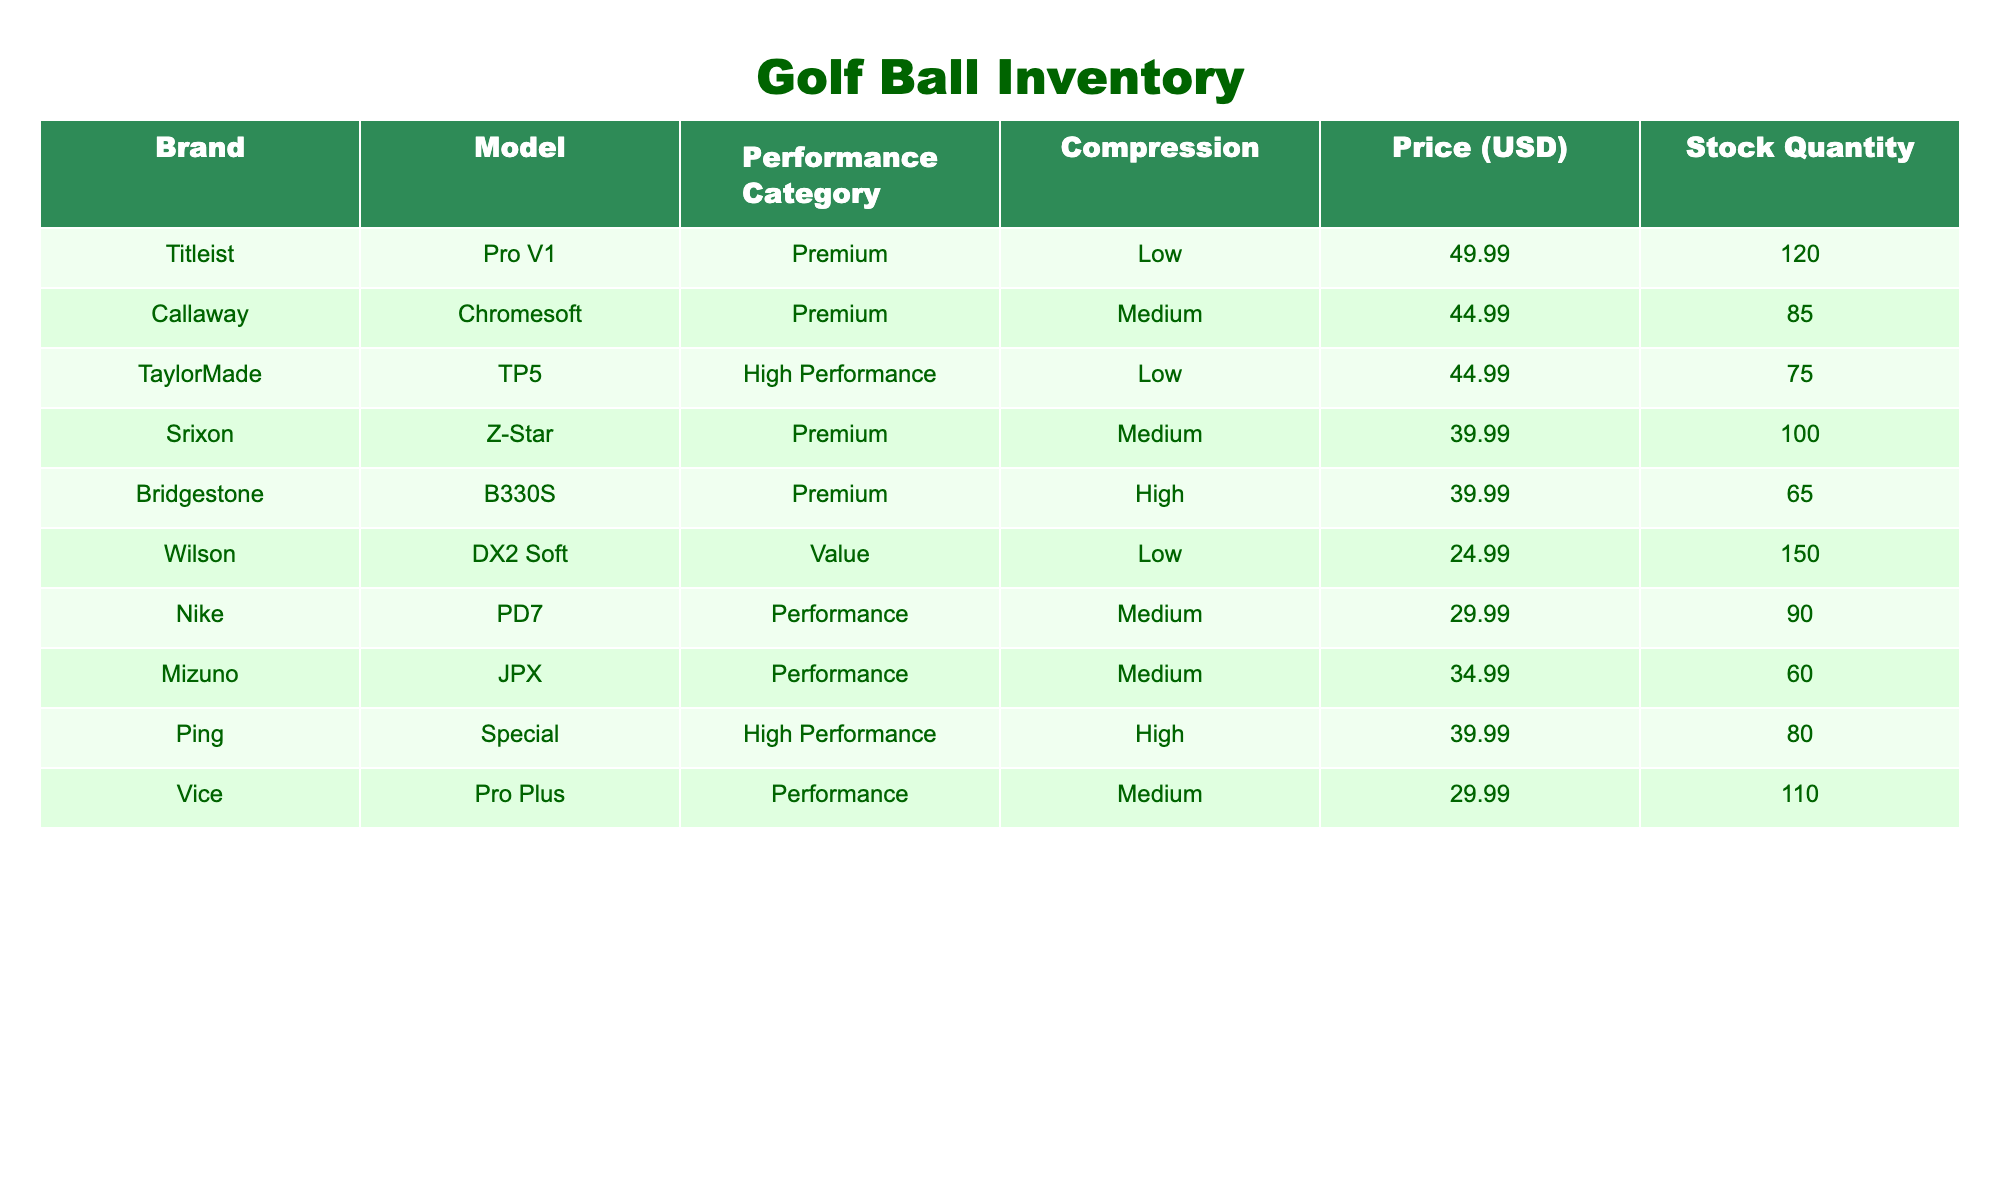What is the price of the Titleist Pro V1 golf ball? The table lists the Titleist Pro V1 under the Brand column, and the corresponding Price (USD) in the same row is $49.99.
Answer: 49.99 How many Srixon Z-Star golf balls are in stock? Looking at the Brand column for Srixon Z-Star, the Stock Quantity shown in that row is 100.
Answer: 100 Which brand has the highest stock quantity? By examining the Stock Quantity column, Wilson with DX2 Soft has 150 stock, more than any other brand.
Answer: Wilson What is the average price of the Premium category golf balls? The Premium category consists of Titleist Pro V1 ($49.99), Callaway Chromesoft ($44.99), Srixon Z-Star ($39.99), and Bridgestone B330S ($39.99). The total is 49.99 + 44.99 + 39.99 + 39.99 = 174.96, and there are 4 items, so the average price is 174.96 / 4 = 43.74.
Answer: 43.74 Is there any golf ball in the Performance category priced higher than $35? The table shows Nike PD7 ($29.99) and Vice Pro Plus ($29.99) as the only performance balls, both priced under $35, so no balls meet this criterion.
Answer: No What is the total stock quantity of all High Performance golf balls combined? The High Performance golf balls listed are TaylorMade TP5 (75 in stock) and Ping Special (80 in stock). Adding these together, 75 + 80 = 155, totaling 155 high-performance balls.
Answer: 155 Is the Callaway Chromesoft golf ball in stock? The stock quantity for Callaway Chromesoft is 85, which is a positive integer, confirming it is in stock.
Answer: Yes How much would it cost to buy all available stock of the Wilson DX2 Soft balls? Wilson DX2 Soft has a price of $24.99 with a stock quantity of 150. Multiplying the price by stock gives 24.99 * 150 = $3,748.50.
Answer: 3748.50 